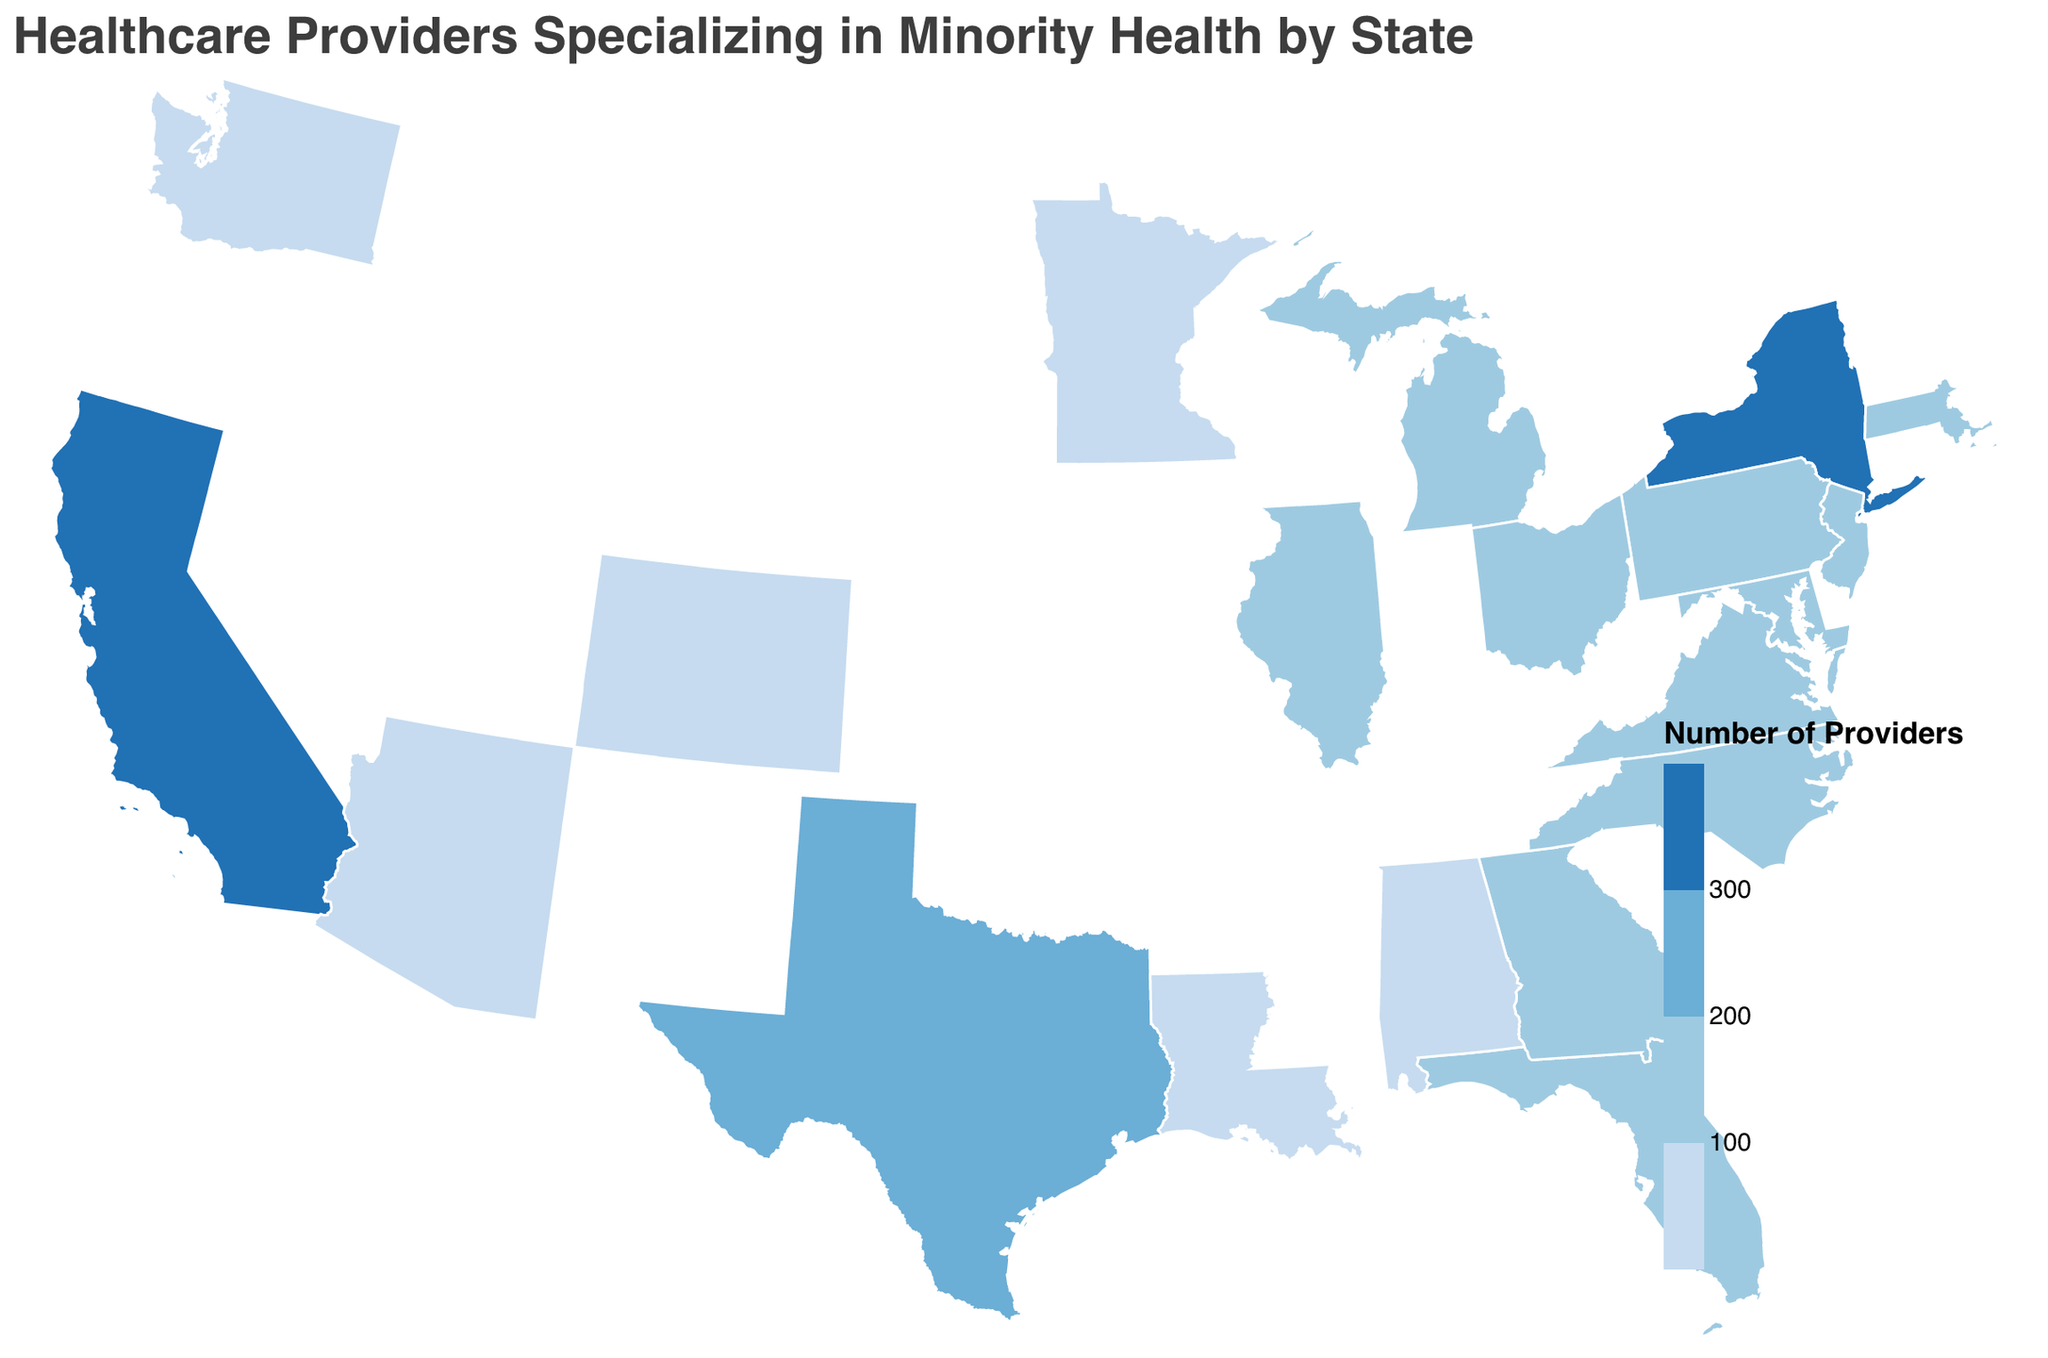Which state has the highest number of healthcare providers specializing in minority health? The figure shows that California has the darkest shade of blue, indicating the highest number of healthcare providers specializing in minority health.
Answer: California What's the total number of healthcare providers specializing in minority health in Texas and New York combined? Texas has 245 providers, and New York has 312 providers, so the total is 245 + 312 = 557.
Answer: 557 Which states have fewer than 100 healthcare providers specializing in minority health? The states with lighter shades of blue on the map represent fewer than 100 providers: Washington (98), Arizona (85), Colorado (79), Minnesota (92), Louisiana (74), and Alabama (68).
Answer: Washington, Arizona, Colorado, Minnesota, Louisiana, Alabama Compare the number of healthcare providers specializing in minority health in Florida and Illinois. Which state has more? Florida has 198 providers, and Illinois has 176 providers. Hence, Florida has more.
Answer: Florida What's the average number of healthcare providers specializing in minority health across the given states? Sum all the values: 387 (California) + 245 (Texas) + 312 (New York) + 198 (Florida) + 176 (Illinois) + 143 (Georgia) + 165 (Massachusetts) + 121 (Michigan) + 137 (Pennsylvania) + 158 (Maryland) + 142 (New Jersey) + 98 (Washington) + 112 (Virginia) + 128 (North Carolina) + 106 (Ohio) + 85 (Arizona) + 79 (Colorado) + 92 (Minnesota) + 74 (Louisiana) + 68 (Alabama) = 3526. Divide by the number of states (20), so the average is 3526 / 20 = 176.3.
Answer: 176.3 Which three states have the lowest number of healthcare providers specializing in minority health? The map indicates the lightest shades of blue in Colorado (79), Louisiana (74), and Alabama (68).
Answer: Colorado, Louisiana, Alabama How many states have more than 200 healthcare providers specializing in minority health? The states illustrated in the two darkest shades of blue (over 200 providers) are California, Texas, and New York. Therefore, three states have more than 200 providers.
Answer: 3 Compare the distribution of healthcare providers specializing in minority health between the East and West coasts. Which coast has a greater total number? East Coast (New York (312) + Massachusetts (165) + Maryland (158) + New Jersey (142) + Virginia (112) + North Carolina (128) = 1017); West Coast (California (387) + Washington (98) = 485). East Coast has 1017 vs. West Coast's 485. So, East Coast has more.
Answer: East Coast 